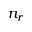Convert formula to latex. <formula><loc_0><loc_0><loc_500><loc_500>n _ { r }</formula> 